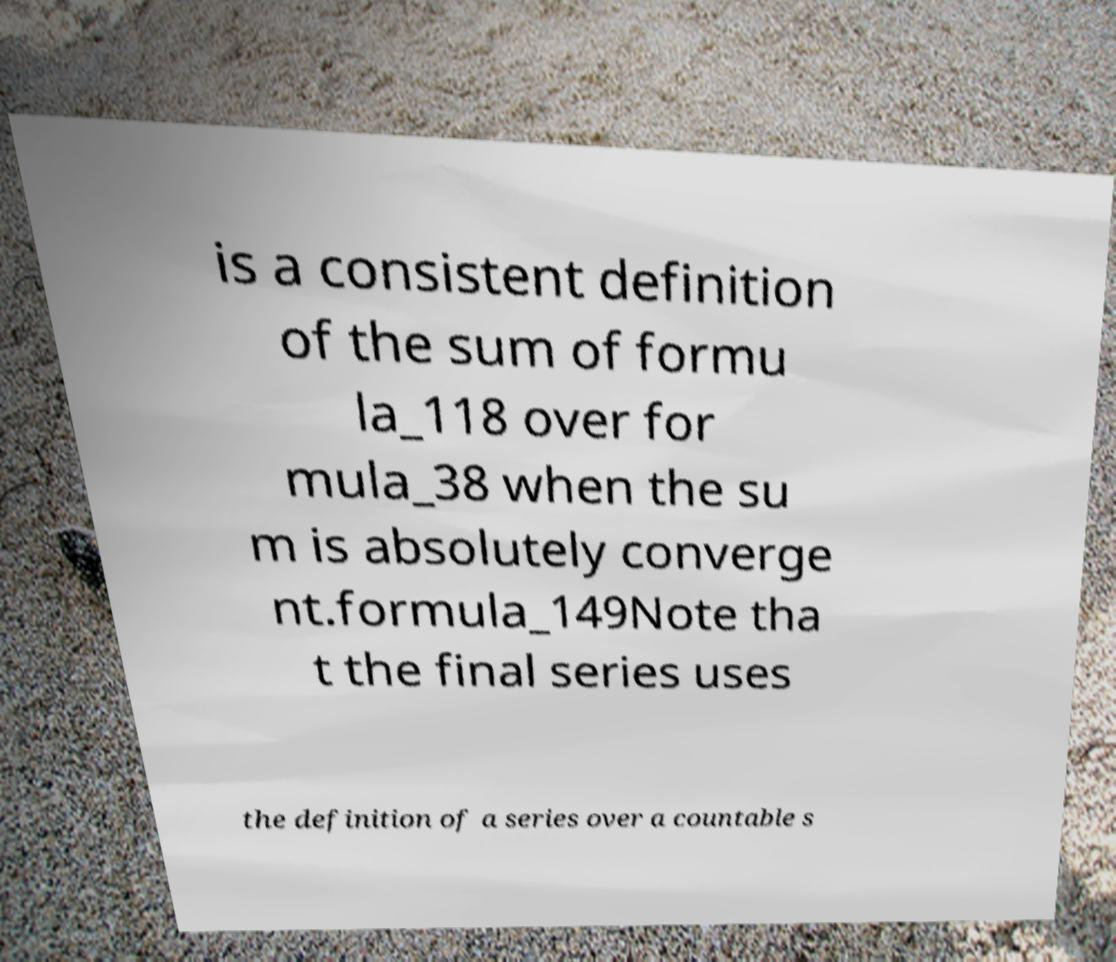For documentation purposes, I need the text within this image transcribed. Could you provide that? is a consistent definition of the sum of formu la_118 over for mula_38 when the su m is absolutely converge nt.formula_149Note tha t the final series uses the definition of a series over a countable s 